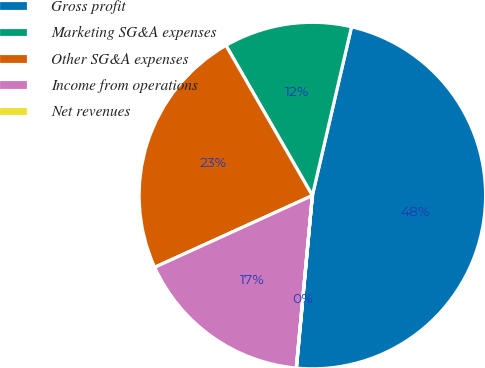Convert chart to OTSL. <chart><loc_0><loc_0><loc_500><loc_500><pie_chart><fcel>Gross profit<fcel>Marketing SG&A expenses<fcel>Other SG&A expenses<fcel>Income from operations<fcel>Net revenues<nl><fcel>47.83%<fcel>11.94%<fcel>23.48%<fcel>16.72%<fcel>0.02%<nl></chart> 